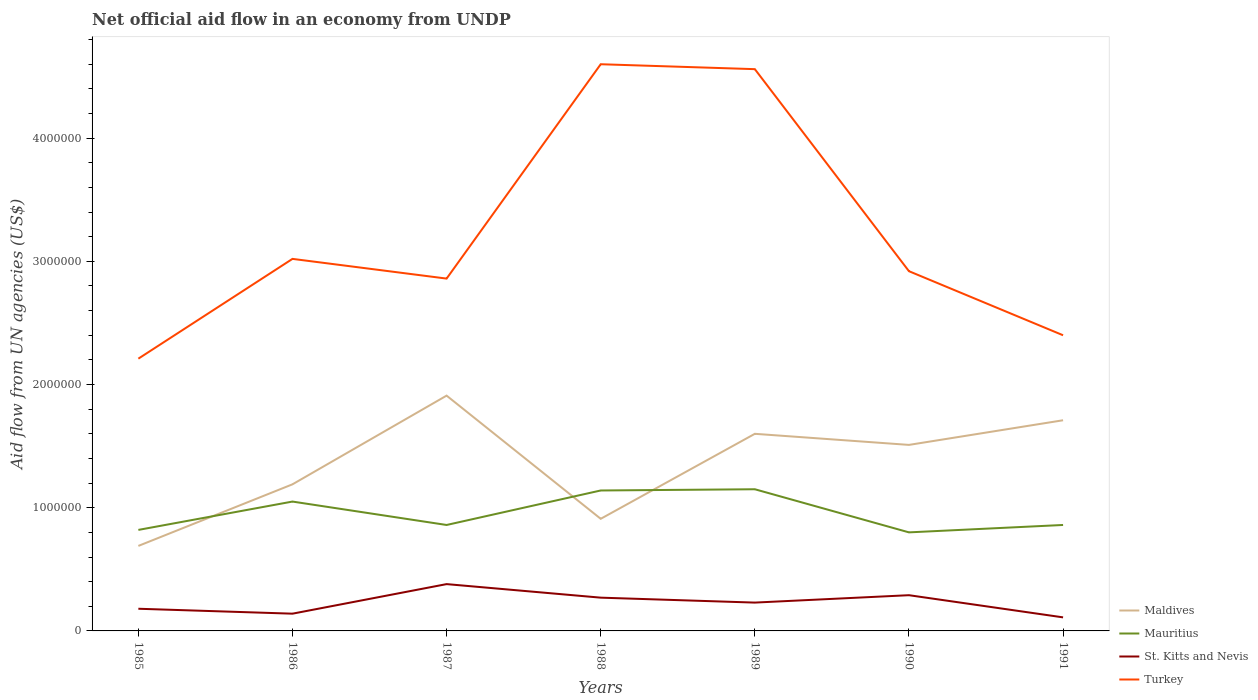How many different coloured lines are there?
Provide a succinct answer. 4. Is the number of lines equal to the number of legend labels?
Your response must be concise. Yes. Across all years, what is the maximum net official aid flow in St. Kitts and Nevis?
Offer a terse response. 1.10e+05. In which year was the net official aid flow in Turkey maximum?
Give a very brief answer. 1985. What is the total net official aid flow in Mauritius in the graph?
Make the answer very short. 3.40e+05. What is the difference between the highest and the second highest net official aid flow in St. Kitts and Nevis?
Ensure brevity in your answer.  2.70e+05. What is the difference between the highest and the lowest net official aid flow in St. Kitts and Nevis?
Give a very brief answer. 4. Is the net official aid flow in Maldives strictly greater than the net official aid flow in St. Kitts and Nevis over the years?
Offer a terse response. No. How many years are there in the graph?
Your answer should be compact. 7. What is the difference between two consecutive major ticks on the Y-axis?
Provide a short and direct response. 1.00e+06. Where does the legend appear in the graph?
Your answer should be compact. Bottom right. How are the legend labels stacked?
Provide a short and direct response. Vertical. What is the title of the graph?
Offer a terse response. Net official aid flow in an economy from UNDP. Does "Ireland" appear as one of the legend labels in the graph?
Your answer should be very brief. No. What is the label or title of the X-axis?
Offer a terse response. Years. What is the label or title of the Y-axis?
Offer a very short reply. Aid flow from UN agencies (US$). What is the Aid flow from UN agencies (US$) of Maldives in 1985?
Your answer should be compact. 6.90e+05. What is the Aid flow from UN agencies (US$) in Mauritius in 1985?
Your response must be concise. 8.20e+05. What is the Aid flow from UN agencies (US$) in Turkey in 1985?
Provide a succinct answer. 2.21e+06. What is the Aid flow from UN agencies (US$) in Maldives in 1986?
Offer a very short reply. 1.19e+06. What is the Aid flow from UN agencies (US$) of Mauritius in 1986?
Offer a terse response. 1.05e+06. What is the Aid flow from UN agencies (US$) in Turkey in 1986?
Provide a short and direct response. 3.02e+06. What is the Aid flow from UN agencies (US$) in Maldives in 1987?
Provide a succinct answer. 1.91e+06. What is the Aid flow from UN agencies (US$) of Mauritius in 1987?
Keep it short and to the point. 8.60e+05. What is the Aid flow from UN agencies (US$) in St. Kitts and Nevis in 1987?
Offer a terse response. 3.80e+05. What is the Aid flow from UN agencies (US$) in Turkey in 1987?
Offer a terse response. 2.86e+06. What is the Aid flow from UN agencies (US$) in Maldives in 1988?
Provide a short and direct response. 9.10e+05. What is the Aid flow from UN agencies (US$) of Mauritius in 1988?
Keep it short and to the point. 1.14e+06. What is the Aid flow from UN agencies (US$) of St. Kitts and Nevis in 1988?
Your answer should be very brief. 2.70e+05. What is the Aid flow from UN agencies (US$) of Turkey in 1988?
Offer a terse response. 4.60e+06. What is the Aid flow from UN agencies (US$) in Maldives in 1989?
Provide a succinct answer. 1.60e+06. What is the Aid flow from UN agencies (US$) of Mauritius in 1989?
Offer a very short reply. 1.15e+06. What is the Aid flow from UN agencies (US$) of St. Kitts and Nevis in 1989?
Ensure brevity in your answer.  2.30e+05. What is the Aid flow from UN agencies (US$) of Turkey in 1989?
Give a very brief answer. 4.56e+06. What is the Aid flow from UN agencies (US$) in Maldives in 1990?
Keep it short and to the point. 1.51e+06. What is the Aid flow from UN agencies (US$) in Turkey in 1990?
Ensure brevity in your answer.  2.92e+06. What is the Aid flow from UN agencies (US$) in Maldives in 1991?
Give a very brief answer. 1.71e+06. What is the Aid flow from UN agencies (US$) of Mauritius in 1991?
Make the answer very short. 8.60e+05. What is the Aid flow from UN agencies (US$) of St. Kitts and Nevis in 1991?
Your answer should be very brief. 1.10e+05. What is the Aid flow from UN agencies (US$) in Turkey in 1991?
Offer a terse response. 2.40e+06. Across all years, what is the maximum Aid flow from UN agencies (US$) in Maldives?
Your answer should be very brief. 1.91e+06. Across all years, what is the maximum Aid flow from UN agencies (US$) in Mauritius?
Keep it short and to the point. 1.15e+06. Across all years, what is the maximum Aid flow from UN agencies (US$) in Turkey?
Your answer should be very brief. 4.60e+06. Across all years, what is the minimum Aid flow from UN agencies (US$) of Maldives?
Offer a terse response. 6.90e+05. Across all years, what is the minimum Aid flow from UN agencies (US$) in St. Kitts and Nevis?
Give a very brief answer. 1.10e+05. Across all years, what is the minimum Aid flow from UN agencies (US$) of Turkey?
Offer a terse response. 2.21e+06. What is the total Aid flow from UN agencies (US$) in Maldives in the graph?
Make the answer very short. 9.52e+06. What is the total Aid flow from UN agencies (US$) of Mauritius in the graph?
Make the answer very short. 6.68e+06. What is the total Aid flow from UN agencies (US$) in St. Kitts and Nevis in the graph?
Provide a succinct answer. 1.60e+06. What is the total Aid flow from UN agencies (US$) of Turkey in the graph?
Make the answer very short. 2.26e+07. What is the difference between the Aid flow from UN agencies (US$) in Maldives in 1985 and that in 1986?
Provide a short and direct response. -5.00e+05. What is the difference between the Aid flow from UN agencies (US$) in Turkey in 1985 and that in 1986?
Give a very brief answer. -8.10e+05. What is the difference between the Aid flow from UN agencies (US$) in Maldives in 1985 and that in 1987?
Provide a short and direct response. -1.22e+06. What is the difference between the Aid flow from UN agencies (US$) in Mauritius in 1985 and that in 1987?
Offer a terse response. -4.00e+04. What is the difference between the Aid flow from UN agencies (US$) of St. Kitts and Nevis in 1985 and that in 1987?
Provide a short and direct response. -2.00e+05. What is the difference between the Aid flow from UN agencies (US$) of Turkey in 1985 and that in 1987?
Make the answer very short. -6.50e+05. What is the difference between the Aid flow from UN agencies (US$) in Maldives in 1985 and that in 1988?
Your answer should be compact. -2.20e+05. What is the difference between the Aid flow from UN agencies (US$) of Mauritius in 1985 and that in 1988?
Offer a very short reply. -3.20e+05. What is the difference between the Aid flow from UN agencies (US$) of Turkey in 1985 and that in 1988?
Provide a short and direct response. -2.39e+06. What is the difference between the Aid flow from UN agencies (US$) in Maldives in 1985 and that in 1989?
Your answer should be very brief. -9.10e+05. What is the difference between the Aid flow from UN agencies (US$) in Mauritius in 1985 and that in 1989?
Your answer should be very brief. -3.30e+05. What is the difference between the Aid flow from UN agencies (US$) of St. Kitts and Nevis in 1985 and that in 1989?
Your answer should be compact. -5.00e+04. What is the difference between the Aid flow from UN agencies (US$) in Turkey in 1985 and that in 1989?
Your response must be concise. -2.35e+06. What is the difference between the Aid flow from UN agencies (US$) of Maldives in 1985 and that in 1990?
Provide a short and direct response. -8.20e+05. What is the difference between the Aid flow from UN agencies (US$) of Mauritius in 1985 and that in 1990?
Make the answer very short. 2.00e+04. What is the difference between the Aid flow from UN agencies (US$) of St. Kitts and Nevis in 1985 and that in 1990?
Offer a very short reply. -1.10e+05. What is the difference between the Aid flow from UN agencies (US$) of Turkey in 1985 and that in 1990?
Provide a succinct answer. -7.10e+05. What is the difference between the Aid flow from UN agencies (US$) in Maldives in 1985 and that in 1991?
Your answer should be compact. -1.02e+06. What is the difference between the Aid flow from UN agencies (US$) in Mauritius in 1985 and that in 1991?
Your answer should be very brief. -4.00e+04. What is the difference between the Aid flow from UN agencies (US$) of Maldives in 1986 and that in 1987?
Keep it short and to the point. -7.20e+05. What is the difference between the Aid flow from UN agencies (US$) in Turkey in 1986 and that in 1987?
Provide a short and direct response. 1.60e+05. What is the difference between the Aid flow from UN agencies (US$) in St. Kitts and Nevis in 1986 and that in 1988?
Offer a very short reply. -1.30e+05. What is the difference between the Aid flow from UN agencies (US$) in Turkey in 1986 and that in 1988?
Your answer should be compact. -1.58e+06. What is the difference between the Aid flow from UN agencies (US$) of Maldives in 1986 and that in 1989?
Keep it short and to the point. -4.10e+05. What is the difference between the Aid flow from UN agencies (US$) of St. Kitts and Nevis in 1986 and that in 1989?
Ensure brevity in your answer.  -9.00e+04. What is the difference between the Aid flow from UN agencies (US$) in Turkey in 1986 and that in 1989?
Give a very brief answer. -1.54e+06. What is the difference between the Aid flow from UN agencies (US$) in Maldives in 1986 and that in 1990?
Provide a short and direct response. -3.20e+05. What is the difference between the Aid flow from UN agencies (US$) in Turkey in 1986 and that in 1990?
Provide a succinct answer. 1.00e+05. What is the difference between the Aid flow from UN agencies (US$) in Maldives in 1986 and that in 1991?
Your answer should be very brief. -5.20e+05. What is the difference between the Aid flow from UN agencies (US$) of St. Kitts and Nevis in 1986 and that in 1991?
Ensure brevity in your answer.  3.00e+04. What is the difference between the Aid flow from UN agencies (US$) of Turkey in 1986 and that in 1991?
Give a very brief answer. 6.20e+05. What is the difference between the Aid flow from UN agencies (US$) in Mauritius in 1987 and that in 1988?
Your answer should be very brief. -2.80e+05. What is the difference between the Aid flow from UN agencies (US$) in Turkey in 1987 and that in 1988?
Provide a short and direct response. -1.74e+06. What is the difference between the Aid flow from UN agencies (US$) in Maldives in 1987 and that in 1989?
Provide a succinct answer. 3.10e+05. What is the difference between the Aid flow from UN agencies (US$) of Mauritius in 1987 and that in 1989?
Your answer should be compact. -2.90e+05. What is the difference between the Aid flow from UN agencies (US$) of St. Kitts and Nevis in 1987 and that in 1989?
Your answer should be compact. 1.50e+05. What is the difference between the Aid flow from UN agencies (US$) in Turkey in 1987 and that in 1989?
Keep it short and to the point. -1.70e+06. What is the difference between the Aid flow from UN agencies (US$) in Maldives in 1987 and that in 1990?
Keep it short and to the point. 4.00e+05. What is the difference between the Aid flow from UN agencies (US$) in Mauritius in 1987 and that in 1990?
Give a very brief answer. 6.00e+04. What is the difference between the Aid flow from UN agencies (US$) of Maldives in 1987 and that in 1991?
Provide a succinct answer. 2.00e+05. What is the difference between the Aid flow from UN agencies (US$) of Maldives in 1988 and that in 1989?
Provide a succinct answer. -6.90e+05. What is the difference between the Aid flow from UN agencies (US$) of Mauritius in 1988 and that in 1989?
Provide a succinct answer. -10000. What is the difference between the Aid flow from UN agencies (US$) of Turkey in 1988 and that in 1989?
Provide a succinct answer. 4.00e+04. What is the difference between the Aid flow from UN agencies (US$) of Maldives in 1988 and that in 1990?
Make the answer very short. -6.00e+05. What is the difference between the Aid flow from UN agencies (US$) in Turkey in 1988 and that in 1990?
Ensure brevity in your answer.  1.68e+06. What is the difference between the Aid flow from UN agencies (US$) in Maldives in 1988 and that in 1991?
Provide a short and direct response. -8.00e+05. What is the difference between the Aid flow from UN agencies (US$) of Mauritius in 1988 and that in 1991?
Your answer should be very brief. 2.80e+05. What is the difference between the Aid flow from UN agencies (US$) in Turkey in 1988 and that in 1991?
Give a very brief answer. 2.20e+06. What is the difference between the Aid flow from UN agencies (US$) in Turkey in 1989 and that in 1990?
Offer a very short reply. 1.64e+06. What is the difference between the Aid flow from UN agencies (US$) of Maldives in 1989 and that in 1991?
Your answer should be very brief. -1.10e+05. What is the difference between the Aid flow from UN agencies (US$) in Mauritius in 1989 and that in 1991?
Keep it short and to the point. 2.90e+05. What is the difference between the Aid flow from UN agencies (US$) in St. Kitts and Nevis in 1989 and that in 1991?
Provide a short and direct response. 1.20e+05. What is the difference between the Aid flow from UN agencies (US$) in Turkey in 1989 and that in 1991?
Offer a terse response. 2.16e+06. What is the difference between the Aid flow from UN agencies (US$) in Mauritius in 1990 and that in 1991?
Give a very brief answer. -6.00e+04. What is the difference between the Aid flow from UN agencies (US$) of Turkey in 1990 and that in 1991?
Keep it short and to the point. 5.20e+05. What is the difference between the Aid flow from UN agencies (US$) in Maldives in 1985 and the Aid flow from UN agencies (US$) in Mauritius in 1986?
Keep it short and to the point. -3.60e+05. What is the difference between the Aid flow from UN agencies (US$) of Maldives in 1985 and the Aid flow from UN agencies (US$) of Turkey in 1986?
Your answer should be compact. -2.33e+06. What is the difference between the Aid flow from UN agencies (US$) in Mauritius in 1985 and the Aid flow from UN agencies (US$) in St. Kitts and Nevis in 1986?
Provide a succinct answer. 6.80e+05. What is the difference between the Aid flow from UN agencies (US$) in Mauritius in 1985 and the Aid flow from UN agencies (US$) in Turkey in 1986?
Give a very brief answer. -2.20e+06. What is the difference between the Aid flow from UN agencies (US$) in St. Kitts and Nevis in 1985 and the Aid flow from UN agencies (US$) in Turkey in 1986?
Offer a terse response. -2.84e+06. What is the difference between the Aid flow from UN agencies (US$) in Maldives in 1985 and the Aid flow from UN agencies (US$) in Turkey in 1987?
Offer a very short reply. -2.17e+06. What is the difference between the Aid flow from UN agencies (US$) of Mauritius in 1985 and the Aid flow from UN agencies (US$) of St. Kitts and Nevis in 1987?
Give a very brief answer. 4.40e+05. What is the difference between the Aid flow from UN agencies (US$) of Mauritius in 1985 and the Aid flow from UN agencies (US$) of Turkey in 1987?
Offer a very short reply. -2.04e+06. What is the difference between the Aid flow from UN agencies (US$) in St. Kitts and Nevis in 1985 and the Aid flow from UN agencies (US$) in Turkey in 1987?
Give a very brief answer. -2.68e+06. What is the difference between the Aid flow from UN agencies (US$) in Maldives in 1985 and the Aid flow from UN agencies (US$) in Mauritius in 1988?
Give a very brief answer. -4.50e+05. What is the difference between the Aid flow from UN agencies (US$) in Maldives in 1985 and the Aid flow from UN agencies (US$) in St. Kitts and Nevis in 1988?
Provide a short and direct response. 4.20e+05. What is the difference between the Aid flow from UN agencies (US$) of Maldives in 1985 and the Aid flow from UN agencies (US$) of Turkey in 1988?
Give a very brief answer. -3.91e+06. What is the difference between the Aid flow from UN agencies (US$) of Mauritius in 1985 and the Aid flow from UN agencies (US$) of Turkey in 1988?
Offer a terse response. -3.78e+06. What is the difference between the Aid flow from UN agencies (US$) of St. Kitts and Nevis in 1985 and the Aid flow from UN agencies (US$) of Turkey in 1988?
Offer a very short reply. -4.42e+06. What is the difference between the Aid flow from UN agencies (US$) of Maldives in 1985 and the Aid flow from UN agencies (US$) of Mauritius in 1989?
Your response must be concise. -4.60e+05. What is the difference between the Aid flow from UN agencies (US$) in Maldives in 1985 and the Aid flow from UN agencies (US$) in Turkey in 1989?
Provide a short and direct response. -3.87e+06. What is the difference between the Aid flow from UN agencies (US$) of Mauritius in 1985 and the Aid flow from UN agencies (US$) of St. Kitts and Nevis in 1989?
Offer a terse response. 5.90e+05. What is the difference between the Aid flow from UN agencies (US$) in Mauritius in 1985 and the Aid flow from UN agencies (US$) in Turkey in 1989?
Ensure brevity in your answer.  -3.74e+06. What is the difference between the Aid flow from UN agencies (US$) of St. Kitts and Nevis in 1985 and the Aid flow from UN agencies (US$) of Turkey in 1989?
Your answer should be compact. -4.38e+06. What is the difference between the Aid flow from UN agencies (US$) of Maldives in 1985 and the Aid flow from UN agencies (US$) of Mauritius in 1990?
Your answer should be very brief. -1.10e+05. What is the difference between the Aid flow from UN agencies (US$) in Maldives in 1985 and the Aid flow from UN agencies (US$) in St. Kitts and Nevis in 1990?
Provide a succinct answer. 4.00e+05. What is the difference between the Aid flow from UN agencies (US$) of Maldives in 1985 and the Aid flow from UN agencies (US$) of Turkey in 1990?
Make the answer very short. -2.23e+06. What is the difference between the Aid flow from UN agencies (US$) of Mauritius in 1985 and the Aid flow from UN agencies (US$) of St. Kitts and Nevis in 1990?
Ensure brevity in your answer.  5.30e+05. What is the difference between the Aid flow from UN agencies (US$) of Mauritius in 1985 and the Aid flow from UN agencies (US$) of Turkey in 1990?
Keep it short and to the point. -2.10e+06. What is the difference between the Aid flow from UN agencies (US$) in St. Kitts and Nevis in 1985 and the Aid flow from UN agencies (US$) in Turkey in 1990?
Provide a short and direct response. -2.74e+06. What is the difference between the Aid flow from UN agencies (US$) in Maldives in 1985 and the Aid flow from UN agencies (US$) in Mauritius in 1991?
Keep it short and to the point. -1.70e+05. What is the difference between the Aid flow from UN agencies (US$) in Maldives in 1985 and the Aid flow from UN agencies (US$) in St. Kitts and Nevis in 1991?
Offer a very short reply. 5.80e+05. What is the difference between the Aid flow from UN agencies (US$) in Maldives in 1985 and the Aid flow from UN agencies (US$) in Turkey in 1991?
Ensure brevity in your answer.  -1.71e+06. What is the difference between the Aid flow from UN agencies (US$) of Mauritius in 1985 and the Aid flow from UN agencies (US$) of St. Kitts and Nevis in 1991?
Offer a terse response. 7.10e+05. What is the difference between the Aid flow from UN agencies (US$) of Mauritius in 1985 and the Aid flow from UN agencies (US$) of Turkey in 1991?
Your response must be concise. -1.58e+06. What is the difference between the Aid flow from UN agencies (US$) in St. Kitts and Nevis in 1985 and the Aid flow from UN agencies (US$) in Turkey in 1991?
Provide a short and direct response. -2.22e+06. What is the difference between the Aid flow from UN agencies (US$) in Maldives in 1986 and the Aid flow from UN agencies (US$) in Mauritius in 1987?
Ensure brevity in your answer.  3.30e+05. What is the difference between the Aid flow from UN agencies (US$) in Maldives in 1986 and the Aid flow from UN agencies (US$) in St. Kitts and Nevis in 1987?
Provide a short and direct response. 8.10e+05. What is the difference between the Aid flow from UN agencies (US$) of Maldives in 1986 and the Aid flow from UN agencies (US$) of Turkey in 1987?
Your answer should be compact. -1.67e+06. What is the difference between the Aid flow from UN agencies (US$) of Mauritius in 1986 and the Aid flow from UN agencies (US$) of St. Kitts and Nevis in 1987?
Your answer should be very brief. 6.70e+05. What is the difference between the Aid flow from UN agencies (US$) in Mauritius in 1986 and the Aid flow from UN agencies (US$) in Turkey in 1987?
Ensure brevity in your answer.  -1.81e+06. What is the difference between the Aid flow from UN agencies (US$) of St. Kitts and Nevis in 1986 and the Aid flow from UN agencies (US$) of Turkey in 1987?
Offer a terse response. -2.72e+06. What is the difference between the Aid flow from UN agencies (US$) of Maldives in 1986 and the Aid flow from UN agencies (US$) of Mauritius in 1988?
Provide a succinct answer. 5.00e+04. What is the difference between the Aid flow from UN agencies (US$) of Maldives in 1986 and the Aid flow from UN agencies (US$) of St. Kitts and Nevis in 1988?
Provide a succinct answer. 9.20e+05. What is the difference between the Aid flow from UN agencies (US$) of Maldives in 1986 and the Aid flow from UN agencies (US$) of Turkey in 1988?
Provide a succinct answer. -3.41e+06. What is the difference between the Aid flow from UN agencies (US$) of Mauritius in 1986 and the Aid flow from UN agencies (US$) of St. Kitts and Nevis in 1988?
Offer a very short reply. 7.80e+05. What is the difference between the Aid flow from UN agencies (US$) in Mauritius in 1986 and the Aid flow from UN agencies (US$) in Turkey in 1988?
Provide a succinct answer. -3.55e+06. What is the difference between the Aid flow from UN agencies (US$) of St. Kitts and Nevis in 1986 and the Aid flow from UN agencies (US$) of Turkey in 1988?
Your answer should be very brief. -4.46e+06. What is the difference between the Aid flow from UN agencies (US$) in Maldives in 1986 and the Aid flow from UN agencies (US$) in St. Kitts and Nevis in 1989?
Offer a terse response. 9.60e+05. What is the difference between the Aid flow from UN agencies (US$) in Maldives in 1986 and the Aid flow from UN agencies (US$) in Turkey in 1989?
Give a very brief answer. -3.37e+06. What is the difference between the Aid flow from UN agencies (US$) of Mauritius in 1986 and the Aid flow from UN agencies (US$) of St. Kitts and Nevis in 1989?
Give a very brief answer. 8.20e+05. What is the difference between the Aid flow from UN agencies (US$) of Mauritius in 1986 and the Aid flow from UN agencies (US$) of Turkey in 1989?
Offer a very short reply. -3.51e+06. What is the difference between the Aid flow from UN agencies (US$) of St. Kitts and Nevis in 1986 and the Aid flow from UN agencies (US$) of Turkey in 1989?
Ensure brevity in your answer.  -4.42e+06. What is the difference between the Aid flow from UN agencies (US$) in Maldives in 1986 and the Aid flow from UN agencies (US$) in St. Kitts and Nevis in 1990?
Ensure brevity in your answer.  9.00e+05. What is the difference between the Aid flow from UN agencies (US$) of Maldives in 1986 and the Aid flow from UN agencies (US$) of Turkey in 1990?
Make the answer very short. -1.73e+06. What is the difference between the Aid flow from UN agencies (US$) in Mauritius in 1986 and the Aid flow from UN agencies (US$) in St. Kitts and Nevis in 1990?
Keep it short and to the point. 7.60e+05. What is the difference between the Aid flow from UN agencies (US$) of Mauritius in 1986 and the Aid flow from UN agencies (US$) of Turkey in 1990?
Provide a succinct answer. -1.87e+06. What is the difference between the Aid flow from UN agencies (US$) of St. Kitts and Nevis in 1986 and the Aid flow from UN agencies (US$) of Turkey in 1990?
Your response must be concise. -2.78e+06. What is the difference between the Aid flow from UN agencies (US$) of Maldives in 1986 and the Aid flow from UN agencies (US$) of St. Kitts and Nevis in 1991?
Offer a very short reply. 1.08e+06. What is the difference between the Aid flow from UN agencies (US$) in Maldives in 1986 and the Aid flow from UN agencies (US$) in Turkey in 1991?
Your answer should be very brief. -1.21e+06. What is the difference between the Aid flow from UN agencies (US$) of Mauritius in 1986 and the Aid flow from UN agencies (US$) of St. Kitts and Nevis in 1991?
Make the answer very short. 9.40e+05. What is the difference between the Aid flow from UN agencies (US$) of Mauritius in 1986 and the Aid flow from UN agencies (US$) of Turkey in 1991?
Your answer should be very brief. -1.35e+06. What is the difference between the Aid flow from UN agencies (US$) of St. Kitts and Nevis in 1986 and the Aid flow from UN agencies (US$) of Turkey in 1991?
Make the answer very short. -2.26e+06. What is the difference between the Aid flow from UN agencies (US$) of Maldives in 1987 and the Aid flow from UN agencies (US$) of Mauritius in 1988?
Make the answer very short. 7.70e+05. What is the difference between the Aid flow from UN agencies (US$) of Maldives in 1987 and the Aid flow from UN agencies (US$) of St. Kitts and Nevis in 1988?
Your answer should be compact. 1.64e+06. What is the difference between the Aid flow from UN agencies (US$) of Maldives in 1987 and the Aid flow from UN agencies (US$) of Turkey in 1988?
Provide a short and direct response. -2.69e+06. What is the difference between the Aid flow from UN agencies (US$) of Mauritius in 1987 and the Aid flow from UN agencies (US$) of St. Kitts and Nevis in 1988?
Offer a very short reply. 5.90e+05. What is the difference between the Aid flow from UN agencies (US$) of Mauritius in 1987 and the Aid flow from UN agencies (US$) of Turkey in 1988?
Your answer should be compact. -3.74e+06. What is the difference between the Aid flow from UN agencies (US$) of St. Kitts and Nevis in 1987 and the Aid flow from UN agencies (US$) of Turkey in 1988?
Offer a very short reply. -4.22e+06. What is the difference between the Aid flow from UN agencies (US$) in Maldives in 1987 and the Aid flow from UN agencies (US$) in Mauritius in 1989?
Make the answer very short. 7.60e+05. What is the difference between the Aid flow from UN agencies (US$) in Maldives in 1987 and the Aid flow from UN agencies (US$) in St. Kitts and Nevis in 1989?
Keep it short and to the point. 1.68e+06. What is the difference between the Aid flow from UN agencies (US$) of Maldives in 1987 and the Aid flow from UN agencies (US$) of Turkey in 1989?
Give a very brief answer. -2.65e+06. What is the difference between the Aid flow from UN agencies (US$) of Mauritius in 1987 and the Aid flow from UN agencies (US$) of St. Kitts and Nevis in 1989?
Provide a short and direct response. 6.30e+05. What is the difference between the Aid flow from UN agencies (US$) of Mauritius in 1987 and the Aid flow from UN agencies (US$) of Turkey in 1989?
Keep it short and to the point. -3.70e+06. What is the difference between the Aid flow from UN agencies (US$) of St. Kitts and Nevis in 1987 and the Aid flow from UN agencies (US$) of Turkey in 1989?
Provide a short and direct response. -4.18e+06. What is the difference between the Aid flow from UN agencies (US$) in Maldives in 1987 and the Aid flow from UN agencies (US$) in Mauritius in 1990?
Your response must be concise. 1.11e+06. What is the difference between the Aid flow from UN agencies (US$) in Maldives in 1987 and the Aid flow from UN agencies (US$) in St. Kitts and Nevis in 1990?
Offer a terse response. 1.62e+06. What is the difference between the Aid flow from UN agencies (US$) in Maldives in 1987 and the Aid flow from UN agencies (US$) in Turkey in 1990?
Give a very brief answer. -1.01e+06. What is the difference between the Aid flow from UN agencies (US$) of Mauritius in 1987 and the Aid flow from UN agencies (US$) of St. Kitts and Nevis in 1990?
Provide a succinct answer. 5.70e+05. What is the difference between the Aid flow from UN agencies (US$) in Mauritius in 1987 and the Aid flow from UN agencies (US$) in Turkey in 1990?
Provide a short and direct response. -2.06e+06. What is the difference between the Aid flow from UN agencies (US$) of St. Kitts and Nevis in 1987 and the Aid flow from UN agencies (US$) of Turkey in 1990?
Your answer should be compact. -2.54e+06. What is the difference between the Aid flow from UN agencies (US$) of Maldives in 1987 and the Aid flow from UN agencies (US$) of Mauritius in 1991?
Give a very brief answer. 1.05e+06. What is the difference between the Aid flow from UN agencies (US$) of Maldives in 1987 and the Aid flow from UN agencies (US$) of St. Kitts and Nevis in 1991?
Provide a short and direct response. 1.80e+06. What is the difference between the Aid flow from UN agencies (US$) in Maldives in 1987 and the Aid flow from UN agencies (US$) in Turkey in 1991?
Your answer should be very brief. -4.90e+05. What is the difference between the Aid flow from UN agencies (US$) of Mauritius in 1987 and the Aid flow from UN agencies (US$) of St. Kitts and Nevis in 1991?
Provide a succinct answer. 7.50e+05. What is the difference between the Aid flow from UN agencies (US$) of Mauritius in 1987 and the Aid flow from UN agencies (US$) of Turkey in 1991?
Keep it short and to the point. -1.54e+06. What is the difference between the Aid flow from UN agencies (US$) in St. Kitts and Nevis in 1987 and the Aid flow from UN agencies (US$) in Turkey in 1991?
Offer a very short reply. -2.02e+06. What is the difference between the Aid flow from UN agencies (US$) in Maldives in 1988 and the Aid flow from UN agencies (US$) in Mauritius in 1989?
Offer a very short reply. -2.40e+05. What is the difference between the Aid flow from UN agencies (US$) in Maldives in 1988 and the Aid flow from UN agencies (US$) in St. Kitts and Nevis in 1989?
Your answer should be very brief. 6.80e+05. What is the difference between the Aid flow from UN agencies (US$) of Maldives in 1988 and the Aid flow from UN agencies (US$) of Turkey in 1989?
Ensure brevity in your answer.  -3.65e+06. What is the difference between the Aid flow from UN agencies (US$) of Mauritius in 1988 and the Aid flow from UN agencies (US$) of St. Kitts and Nevis in 1989?
Make the answer very short. 9.10e+05. What is the difference between the Aid flow from UN agencies (US$) of Mauritius in 1988 and the Aid flow from UN agencies (US$) of Turkey in 1989?
Give a very brief answer. -3.42e+06. What is the difference between the Aid flow from UN agencies (US$) in St. Kitts and Nevis in 1988 and the Aid flow from UN agencies (US$) in Turkey in 1989?
Your answer should be compact. -4.29e+06. What is the difference between the Aid flow from UN agencies (US$) of Maldives in 1988 and the Aid flow from UN agencies (US$) of Mauritius in 1990?
Ensure brevity in your answer.  1.10e+05. What is the difference between the Aid flow from UN agencies (US$) of Maldives in 1988 and the Aid flow from UN agencies (US$) of St. Kitts and Nevis in 1990?
Make the answer very short. 6.20e+05. What is the difference between the Aid flow from UN agencies (US$) in Maldives in 1988 and the Aid flow from UN agencies (US$) in Turkey in 1990?
Provide a short and direct response. -2.01e+06. What is the difference between the Aid flow from UN agencies (US$) of Mauritius in 1988 and the Aid flow from UN agencies (US$) of St. Kitts and Nevis in 1990?
Your answer should be compact. 8.50e+05. What is the difference between the Aid flow from UN agencies (US$) in Mauritius in 1988 and the Aid flow from UN agencies (US$) in Turkey in 1990?
Make the answer very short. -1.78e+06. What is the difference between the Aid flow from UN agencies (US$) of St. Kitts and Nevis in 1988 and the Aid flow from UN agencies (US$) of Turkey in 1990?
Provide a short and direct response. -2.65e+06. What is the difference between the Aid flow from UN agencies (US$) of Maldives in 1988 and the Aid flow from UN agencies (US$) of Turkey in 1991?
Give a very brief answer. -1.49e+06. What is the difference between the Aid flow from UN agencies (US$) in Mauritius in 1988 and the Aid flow from UN agencies (US$) in St. Kitts and Nevis in 1991?
Keep it short and to the point. 1.03e+06. What is the difference between the Aid flow from UN agencies (US$) of Mauritius in 1988 and the Aid flow from UN agencies (US$) of Turkey in 1991?
Make the answer very short. -1.26e+06. What is the difference between the Aid flow from UN agencies (US$) of St. Kitts and Nevis in 1988 and the Aid flow from UN agencies (US$) of Turkey in 1991?
Your response must be concise. -2.13e+06. What is the difference between the Aid flow from UN agencies (US$) of Maldives in 1989 and the Aid flow from UN agencies (US$) of St. Kitts and Nevis in 1990?
Make the answer very short. 1.31e+06. What is the difference between the Aid flow from UN agencies (US$) in Maldives in 1989 and the Aid flow from UN agencies (US$) in Turkey in 1990?
Ensure brevity in your answer.  -1.32e+06. What is the difference between the Aid flow from UN agencies (US$) in Mauritius in 1989 and the Aid flow from UN agencies (US$) in St. Kitts and Nevis in 1990?
Offer a very short reply. 8.60e+05. What is the difference between the Aid flow from UN agencies (US$) in Mauritius in 1989 and the Aid flow from UN agencies (US$) in Turkey in 1990?
Provide a short and direct response. -1.77e+06. What is the difference between the Aid flow from UN agencies (US$) of St. Kitts and Nevis in 1989 and the Aid flow from UN agencies (US$) of Turkey in 1990?
Your response must be concise. -2.69e+06. What is the difference between the Aid flow from UN agencies (US$) in Maldives in 1989 and the Aid flow from UN agencies (US$) in Mauritius in 1991?
Provide a succinct answer. 7.40e+05. What is the difference between the Aid flow from UN agencies (US$) of Maldives in 1989 and the Aid flow from UN agencies (US$) of St. Kitts and Nevis in 1991?
Your answer should be compact. 1.49e+06. What is the difference between the Aid flow from UN agencies (US$) of Maldives in 1989 and the Aid flow from UN agencies (US$) of Turkey in 1991?
Provide a short and direct response. -8.00e+05. What is the difference between the Aid flow from UN agencies (US$) in Mauritius in 1989 and the Aid flow from UN agencies (US$) in St. Kitts and Nevis in 1991?
Your response must be concise. 1.04e+06. What is the difference between the Aid flow from UN agencies (US$) of Mauritius in 1989 and the Aid flow from UN agencies (US$) of Turkey in 1991?
Ensure brevity in your answer.  -1.25e+06. What is the difference between the Aid flow from UN agencies (US$) in St. Kitts and Nevis in 1989 and the Aid flow from UN agencies (US$) in Turkey in 1991?
Offer a terse response. -2.17e+06. What is the difference between the Aid flow from UN agencies (US$) in Maldives in 1990 and the Aid flow from UN agencies (US$) in Mauritius in 1991?
Give a very brief answer. 6.50e+05. What is the difference between the Aid flow from UN agencies (US$) of Maldives in 1990 and the Aid flow from UN agencies (US$) of St. Kitts and Nevis in 1991?
Make the answer very short. 1.40e+06. What is the difference between the Aid flow from UN agencies (US$) in Maldives in 1990 and the Aid flow from UN agencies (US$) in Turkey in 1991?
Provide a short and direct response. -8.90e+05. What is the difference between the Aid flow from UN agencies (US$) in Mauritius in 1990 and the Aid flow from UN agencies (US$) in St. Kitts and Nevis in 1991?
Make the answer very short. 6.90e+05. What is the difference between the Aid flow from UN agencies (US$) in Mauritius in 1990 and the Aid flow from UN agencies (US$) in Turkey in 1991?
Make the answer very short. -1.60e+06. What is the difference between the Aid flow from UN agencies (US$) in St. Kitts and Nevis in 1990 and the Aid flow from UN agencies (US$) in Turkey in 1991?
Provide a succinct answer. -2.11e+06. What is the average Aid flow from UN agencies (US$) of Maldives per year?
Your answer should be very brief. 1.36e+06. What is the average Aid flow from UN agencies (US$) in Mauritius per year?
Your response must be concise. 9.54e+05. What is the average Aid flow from UN agencies (US$) of St. Kitts and Nevis per year?
Offer a terse response. 2.29e+05. What is the average Aid flow from UN agencies (US$) in Turkey per year?
Your answer should be very brief. 3.22e+06. In the year 1985, what is the difference between the Aid flow from UN agencies (US$) of Maldives and Aid flow from UN agencies (US$) of Mauritius?
Offer a terse response. -1.30e+05. In the year 1985, what is the difference between the Aid flow from UN agencies (US$) in Maldives and Aid flow from UN agencies (US$) in St. Kitts and Nevis?
Make the answer very short. 5.10e+05. In the year 1985, what is the difference between the Aid flow from UN agencies (US$) in Maldives and Aid flow from UN agencies (US$) in Turkey?
Your response must be concise. -1.52e+06. In the year 1985, what is the difference between the Aid flow from UN agencies (US$) of Mauritius and Aid flow from UN agencies (US$) of St. Kitts and Nevis?
Your response must be concise. 6.40e+05. In the year 1985, what is the difference between the Aid flow from UN agencies (US$) in Mauritius and Aid flow from UN agencies (US$) in Turkey?
Make the answer very short. -1.39e+06. In the year 1985, what is the difference between the Aid flow from UN agencies (US$) in St. Kitts and Nevis and Aid flow from UN agencies (US$) in Turkey?
Ensure brevity in your answer.  -2.03e+06. In the year 1986, what is the difference between the Aid flow from UN agencies (US$) of Maldives and Aid flow from UN agencies (US$) of St. Kitts and Nevis?
Give a very brief answer. 1.05e+06. In the year 1986, what is the difference between the Aid flow from UN agencies (US$) in Maldives and Aid flow from UN agencies (US$) in Turkey?
Ensure brevity in your answer.  -1.83e+06. In the year 1986, what is the difference between the Aid flow from UN agencies (US$) of Mauritius and Aid flow from UN agencies (US$) of St. Kitts and Nevis?
Your answer should be very brief. 9.10e+05. In the year 1986, what is the difference between the Aid flow from UN agencies (US$) in Mauritius and Aid flow from UN agencies (US$) in Turkey?
Provide a succinct answer. -1.97e+06. In the year 1986, what is the difference between the Aid flow from UN agencies (US$) in St. Kitts and Nevis and Aid flow from UN agencies (US$) in Turkey?
Provide a short and direct response. -2.88e+06. In the year 1987, what is the difference between the Aid flow from UN agencies (US$) of Maldives and Aid flow from UN agencies (US$) of Mauritius?
Offer a very short reply. 1.05e+06. In the year 1987, what is the difference between the Aid flow from UN agencies (US$) in Maldives and Aid flow from UN agencies (US$) in St. Kitts and Nevis?
Offer a terse response. 1.53e+06. In the year 1987, what is the difference between the Aid flow from UN agencies (US$) in Maldives and Aid flow from UN agencies (US$) in Turkey?
Your answer should be compact. -9.50e+05. In the year 1987, what is the difference between the Aid flow from UN agencies (US$) of St. Kitts and Nevis and Aid flow from UN agencies (US$) of Turkey?
Ensure brevity in your answer.  -2.48e+06. In the year 1988, what is the difference between the Aid flow from UN agencies (US$) in Maldives and Aid flow from UN agencies (US$) in St. Kitts and Nevis?
Ensure brevity in your answer.  6.40e+05. In the year 1988, what is the difference between the Aid flow from UN agencies (US$) of Maldives and Aid flow from UN agencies (US$) of Turkey?
Keep it short and to the point. -3.69e+06. In the year 1988, what is the difference between the Aid flow from UN agencies (US$) in Mauritius and Aid flow from UN agencies (US$) in St. Kitts and Nevis?
Keep it short and to the point. 8.70e+05. In the year 1988, what is the difference between the Aid flow from UN agencies (US$) of Mauritius and Aid flow from UN agencies (US$) of Turkey?
Ensure brevity in your answer.  -3.46e+06. In the year 1988, what is the difference between the Aid flow from UN agencies (US$) in St. Kitts and Nevis and Aid flow from UN agencies (US$) in Turkey?
Offer a terse response. -4.33e+06. In the year 1989, what is the difference between the Aid flow from UN agencies (US$) of Maldives and Aid flow from UN agencies (US$) of Mauritius?
Keep it short and to the point. 4.50e+05. In the year 1989, what is the difference between the Aid flow from UN agencies (US$) in Maldives and Aid flow from UN agencies (US$) in St. Kitts and Nevis?
Provide a short and direct response. 1.37e+06. In the year 1989, what is the difference between the Aid flow from UN agencies (US$) in Maldives and Aid flow from UN agencies (US$) in Turkey?
Your answer should be compact. -2.96e+06. In the year 1989, what is the difference between the Aid flow from UN agencies (US$) of Mauritius and Aid flow from UN agencies (US$) of St. Kitts and Nevis?
Keep it short and to the point. 9.20e+05. In the year 1989, what is the difference between the Aid flow from UN agencies (US$) in Mauritius and Aid flow from UN agencies (US$) in Turkey?
Keep it short and to the point. -3.41e+06. In the year 1989, what is the difference between the Aid flow from UN agencies (US$) of St. Kitts and Nevis and Aid flow from UN agencies (US$) of Turkey?
Your response must be concise. -4.33e+06. In the year 1990, what is the difference between the Aid flow from UN agencies (US$) in Maldives and Aid flow from UN agencies (US$) in Mauritius?
Provide a succinct answer. 7.10e+05. In the year 1990, what is the difference between the Aid flow from UN agencies (US$) of Maldives and Aid flow from UN agencies (US$) of St. Kitts and Nevis?
Offer a very short reply. 1.22e+06. In the year 1990, what is the difference between the Aid flow from UN agencies (US$) in Maldives and Aid flow from UN agencies (US$) in Turkey?
Your answer should be compact. -1.41e+06. In the year 1990, what is the difference between the Aid flow from UN agencies (US$) of Mauritius and Aid flow from UN agencies (US$) of St. Kitts and Nevis?
Make the answer very short. 5.10e+05. In the year 1990, what is the difference between the Aid flow from UN agencies (US$) of Mauritius and Aid flow from UN agencies (US$) of Turkey?
Keep it short and to the point. -2.12e+06. In the year 1990, what is the difference between the Aid flow from UN agencies (US$) in St. Kitts and Nevis and Aid flow from UN agencies (US$) in Turkey?
Give a very brief answer. -2.63e+06. In the year 1991, what is the difference between the Aid flow from UN agencies (US$) in Maldives and Aid flow from UN agencies (US$) in Mauritius?
Your response must be concise. 8.50e+05. In the year 1991, what is the difference between the Aid flow from UN agencies (US$) of Maldives and Aid flow from UN agencies (US$) of St. Kitts and Nevis?
Offer a very short reply. 1.60e+06. In the year 1991, what is the difference between the Aid flow from UN agencies (US$) of Maldives and Aid flow from UN agencies (US$) of Turkey?
Your response must be concise. -6.90e+05. In the year 1991, what is the difference between the Aid flow from UN agencies (US$) in Mauritius and Aid flow from UN agencies (US$) in St. Kitts and Nevis?
Provide a short and direct response. 7.50e+05. In the year 1991, what is the difference between the Aid flow from UN agencies (US$) in Mauritius and Aid flow from UN agencies (US$) in Turkey?
Ensure brevity in your answer.  -1.54e+06. In the year 1991, what is the difference between the Aid flow from UN agencies (US$) of St. Kitts and Nevis and Aid flow from UN agencies (US$) of Turkey?
Keep it short and to the point. -2.29e+06. What is the ratio of the Aid flow from UN agencies (US$) of Maldives in 1985 to that in 1986?
Ensure brevity in your answer.  0.58. What is the ratio of the Aid flow from UN agencies (US$) in Mauritius in 1985 to that in 1986?
Give a very brief answer. 0.78. What is the ratio of the Aid flow from UN agencies (US$) of Turkey in 1985 to that in 1986?
Your answer should be very brief. 0.73. What is the ratio of the Aid flow from UN agencies (US$) of Maldives in 1985 to that in 1987?
Your answer should be compact. 0.36. What is the ratio of the Aid flow from UN agencies (US$) of Mauritius in 1985 to that in 1987?
Make the answer very short. 0.95. What is the ratio of the Aid flow from UN agencies (US$) of St. Kitts and Nevis in 1985 to that in 1987?
Offer a terse response. 0.47. What is the ratio of the Aid flow from UN agencies (US$) of Turkey in 1985 to that in 1987?
Keep it short and to the point. 0.77. What is the ratio of the Aid flow from UN agencies (US$) of Maldives in 1985 to that in 1988?
Give a very brief answer. 0.76. What is the ratio of the Aid flow from UN agencies (US$) of Mauritius in 1985 to that in 1988?
Make the answer very short. 0.72. What is the ratio of the Aid flow from UN agencies (US$) in St. Kitts and Nevis in 1985 to that in 1988?
Ensure brevity in your answer.  0.67. What is the ratio of the Aid flow from UN agencies (US$) in Turkey in 1985 to that in 1988?
Your answer should be compact. 0.48. What is the ratio of the Aid flow from UN agencies (US$) of Maldives in 1985 to that in 1989?
Provide a succinct answer. 0.43. What is the ratio of the Aid flow from UN agencies (US$) in Mauritius in 1985 to that in 1989?
Provide a succinct answer. 0.71. What is the ratio of the Aid flow from UN agencies (US$) of St. Kitts and Nevis in 1985 to that in 1989?
Your answer should be compact. 0.78. What is the ratio of the Aid flow from UN agencies (US$) in Turkey in 1985 to that in 1989?
Give a very brief answer. 0.48. What is the ratio of the Aid flow from UN agencies (US$) in Maldives in 1985 to that in 1990?
Your answer should be very brief. 0.46. What is the ratio of the Aid flow from UN agencies (US$) of Mauritius in 1985 to that in 1990?
Offer a very short reply. 1.02. What is the ratio of the Aid flow from UN agencies (US$) of St. Kitts and Nevis in 1985 to that in 1990?
Make the answer very short. 0.62. What is the ratio of the Aid flow from UN agencies (US$) in Turkey in 1985 to that in 1990?
Your response must be concise. 0.76. What is the ratio of the Aid flow from UN agencies (US$) of Maldives in 1985 to that in 1991?
Keep it short and to the point. 0.4. What is the ratio of the Aid flow from UN agencies (US$) of Mauritius in 1985 to that in 1991?
Offer a very short reply. 0.95. What is the ratio of the Aid flow from UN agencies (US$) of St. Kitts and Nevis in 1985 to that in 1991?
Provide a short and direct response. 1.64. What is the ratio of the Aid flow from UN agencies (US$) of Turkey in 1985 to that in 1991?
Provide a short and direct response. 0.92. What is the ratio of the Aid flow from UN agencies (US$) of Maldives in 1986 to that in 1987?
Your answer should be compact. 0.62. What is the ratio of the Aid flow from UN agencies (US$) in Mauritius in 1986 to that in 1987?
Provide a succinct answer. 1.22. What is the ratio of the Aid flow from UN agencies (US$) of St. Kitts and Nevis in 1986 to that in 1987?
Ensure brevity in your answer.  0.37. What is the ratio of the Aid flow from UN agencies (US$) in Turkey in 1986 to that in 1987?
Your answer should be very brief. 1.06. What is the ratio of the Aid flow from UN agencies (US$) of Maldives in 1986 to that in 1988?
Your response must be concise. 1.31. What is the ratio of the Aid flow from UN agencies (US$) in Mauritius in 1986 to that in 1988?
Offer a terse response. 0.92. What is the ratio of the Aid flow from UN agencies (US$) of St. Kitts and Nevis in 1986 to that in 1988?
Offer a terse response. 0.52. What is the ratio of the Aid flow from UN agencies (US$) in Turkey in 1986 to that in 1988?
Your answer should be compact. 0.66. What is the ratio of the Aid flow from UN agencies (US$) of Maldives in 1986 to that in 1989?
Keep it short and to the point. 0.74. What is the ratio of the Aid flow from UN agencies (US$) in Mauritius in 1986 to that in 1989?
Provide a succinct answer. 0.91. What is the ratio of the Aid flow from UN agencies (US$) of St. Kitts and Nevis in 1986 to that in 1989?
Provide a succinct answer. 0.61. What is the ratio of the Aid flow from UN agencies (US$) in Turkey in 1986 to that in 1989?
Keep it short and to the point. 0.66. What is the ratio of the Aid flow from UN agencies (US$) in Maldives in 1986 to that in 1990?
Your answer should be very brief. 0.79. What is the ratio of the Aid flow from UN agencies (US$) of Mauritius in 1986 to that in 1990?
Your response must be concise. 1.31. What is the ratio of the Aid flow from UN agencies (US$) in St. Kitts and Nevis in 1986 to that in 1990?
Give a very brief answer. 0.48. What is the ratio of the Aid flow from UN agencies (US$) of Turkey in 1986 to that in 1990?
Give a very brief answer. 1.03. What is the ratio of the Aid flow from UN agencies (US$) of Maldives in 1986 to that in 1991?
Keep it short and to the point. 0.7. What is the ratio of the Aid flow from UN agencies (US$) of Mauritius in 1986 to that in 1991?
Provide a short and direct response. 1.22. What is the ratio of the Aid flow from UN agencies (US$) of St. Kitts and Nevis in 1986 to that in 1991?
Provide a succinct answer. 1.27. What is the ratio of the Aid flow from UN agencies (US$) in Turkey in 1986 to that in 1991?
Provide a succinct answer. 1.26. What is the ratio of the Aid flow from UN agencies (US$) in Maldives in 1987 to that in 1988?
Keep it short and to the point. 2.1. What is the ratio of the Aid flow from UN agencies (US$) in Mauritius in 1987 to that in 1988?
Keep it short and to the point. 0.75. What is the ratio of the Aid flow from UN agencies (US$) of St. Kitts and Nevis in 1987 to that in 1988?
Offer a terse response. 1.41. What is the ratio of the Aid flow from UN agencies (US$) in Turkey in 1987 to that in 1988?
Your answer should be very brief. 0.62. What is the ratio of the Aid flow from UN agencies (US$) in Maldives in 1987 to that in 1989?
Give a very brief answer. 1.19. What is the ratio of the Aid flow from UN agencies (US$) of Mauritius in 1987 to that in 1989?
Your answer should be very brief. 0.75. What is the ratio of the Aid flow from UN agencies (US$) of St. Kitts and Nevis in 1987 to that in 1989?
Provide a short and direct response. 1.65. What is the ratio of the Aid flow from UN agencies (US$) of Turkey in 1987 to that in 1989?
Make the answer very short. 0.63. What is the ratio of the Aid flow from UN agencies (US$) in Maldives in 1987 to that in 1990?
Provide a succinct answer. 1.26. What is the ratio of the Aid flow from UN agencies (US$) of Mauritius in 1987 to that in 1990?
Your response must be concise. 1.07. What is the ratio of the Aid flow from UN agencies (US$) of St. Kitts and Nevis in 1987 to that in 1990?
Provide a succinct answer. 1.31. What is the ratio of the Aid flow from UN agencies (US$) in Turkey in 1987 to that in 1990?
Give a very brief answer. 0.98. What is the ratio of the Aid flow from UN agencies (US$) of Maldives in 1987 to that in 1991?
Offer a very short reply. 1.12. What is the ratio of the Aid flow from UN agencies (US$) in Mauritius in 1987 to that in 1991?
Provide a short and direct response. 1. What is the ratio of the Aid flow from UN agencies (US$) in St. Kitts and Nevis in 1987 to that in 1991?
Your answer should be very brief. 3.45. What is the ratio of the Aid flow from UN agencies (US$) of Turkey in 1987 to that in 1991?
Your answer should be very brief. 1.19. What is the ratio of the Aid flow from UN agencies (US$) of Maldives in 1988 to that in 1989?
Make the answer very short. 0.57. What is the ratio of the Aid flow from UN agencies (US$) of Mauritius in 1988 to that in 1989?
Your response must be concise. 0.99. What is the ratio of the Aid flow from UN agencies (US$) in St. Kitts and Nevis in 1988 to that in 1989?
Ensure brevity in your answer.  1.17. What is the ratio of the Aid flow from UN agencies (US$) in Turkey in 1988 to that in 1989?
Offer a terse response. 1.01. What is the ratio of the Aid flow from UN agencies (US$) of Maldives in 1988 to that in 1990?
Provide a short and direct response. 0.6. What is the ratio of the Aid flow from UN agencies (US$) in Mauritius in 1988 to that in 1990?
Ensure brevity in your answer.  1.43. What is the ratio of the Aid flow from UN agencies (US$) in St. Kitts and Nevis in 1988 to that in 1990?
Give a very brief answer. 0.93. What is the ratio of the Aid flow from UN agencies (US$) in Turkey in 1988 to that in 1990?
Offer a very short reply. 1.58. What is the ratio of the Aid flow from UN agencies (US$) in Maldives in 1988 to that in 1991?
Your answer should be compact. 0.53. What is the ratio of the Aid flow from UN agencies (US$) of Mauritius in 1988 to that in 1991?
Your response must be concise. 1.33. What is the ratio of the Aid flow from UN agencies (US$) in St. Kitts and Nevis in 1988 to that in 1991?
Keep it short and to the point. 2.45. What is the ratio of the Aid flow from UN agencies (US$) in Turkey in 1988 to that in 1991?
Your response must be concise. 1.92. What is the ratio of the Aid flow from UN agencies (US$) of Maldives in 1989 to that in 1990?
Offer a very short reply. 1.06. What is the ratio of the Aid flow from UN agencies (US$) in Mauritius in 1989 to that in 1990?
Give a very brief answer. 1.44. What is the ratio of the Aid flow from UN agencies (US$) in St. Kitts and Nevis in 1989 to that in 1990?
Your response must be concise. 0.79. What is the ratio of the Aid flow from UN agencies (US$) of Turkey in 1989 to that in 1990?
Keep it short and to the point. 1.56. What is the ratio of the Aid flow from UN agencies (US$) in Maldives in 1989 to that in 1991?
Provide a succinct answer. 0.94. What is the ratio of the Aid flow from UN agencies (US$) in Mauritius in 1989 to that in 1991?
Ensure brevity in your answer.  1.34. What is the ratio of the Aid flow from UN agencies (US$) of St. Kitts and Nevis in 1989 to that in 1991?
Make the answer very short. 2.09. What is the ratio of the Aid flow from UN agencies (US$) of Maldives in 1990 to that in 1991?
Offer a terse response. 0.88. What is the ratio of the Aid flow from UN agencies (US$) in Mauritius in 1990 to that in 1991?
Keep it short and to the point. 0.93. What is the ratio of the Aid flow from UN agencies (US$) in St. Kitts and Nevis in 1990 to that in 1991?
Your answer should be compact. 2.64. What is the ratio of the Aid flow from UN agencies (US$) in Turkey in 1990 to that in 1991?
Your answer should be very brief. 1.22. What is the difference between the highest and the second highest Aid flow from UN agencies (US$) of St. Kitts and Nevis?
Provide a short and direct response. 9.00e+04. What is the difference between the highest and the lowest Aid flow from UN agencies (US$) of Maldives?
Your answer should be very brief. 1.22e+06. What is the difference between the highest and the lowest Aid flow from UN agencies (US$) of Turkey?
Make the answer very short. 2.39e+06. 